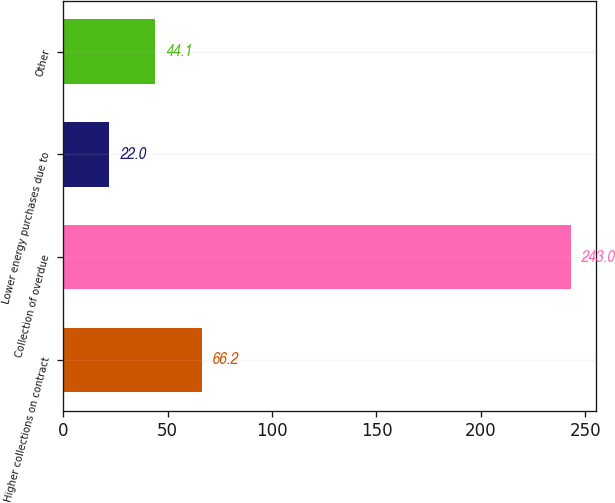<chart> <loc_0><loc_0><loc_500><loc_500><bar_chart><fcel>Higher collections on contract<fcel>Collection of overdue<fcel>Lower energy purchases due to<fcel>Other<nl><fcel>66.2<fcel>243<fcel>22<fcel>44.1<nl></chart> 